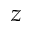<formula> <loc_0><loc_0><loc_500><loc_500>z</formula> 